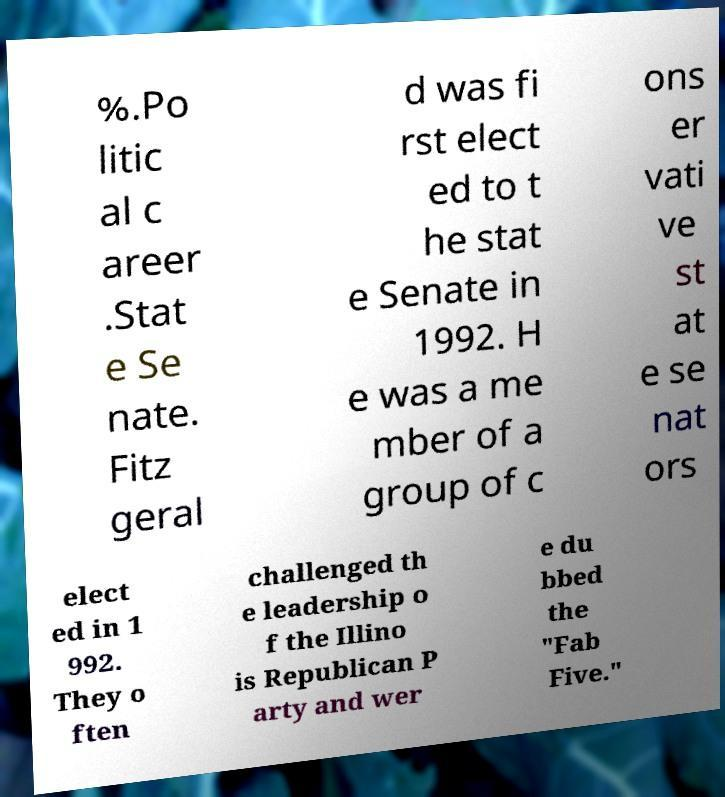Please read and relay the text visible in this image. What does it say? %.Po litic al c areer .Stat e Se nate. Fitz geral d was fi rst elect ed to t he stat e Senate in 1992. H e was a me mber of a group of c ons er vati ve st at e se nat ors elect ed in 1 992. They o ften challenged th e leadership o f the Illino is Republican P arty and wer e du bbed the "Fab Five." 